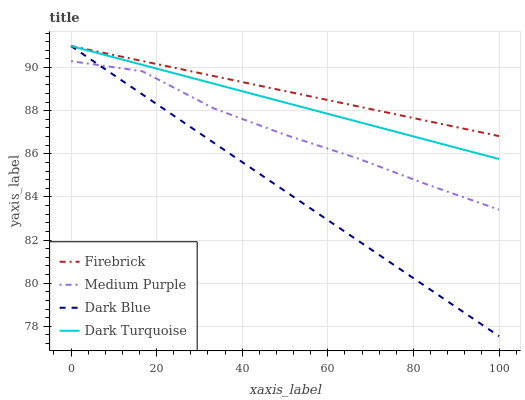Does Firebrick have the minimum area under the curve?
Answer yes or no. No. Does Dark Blue have the maximum area under the curve?
Answer yes or no. No. Is Dark Blue the smoothest?
Answer yes or no. No. Is Dark Blue the roughest?
Answer yes or no. No. Does Firebrick have the lowest value?
Answer yes or no. No. Is Medium Purple less than Dark Turquoise?
Answer yes or no. Yes. Is Dark Turquoise greater than Medium Purple?
Answer yes or no. Yes. Does Medium Purple intersect Dark Turquoise?
Answer yes or no. No. 